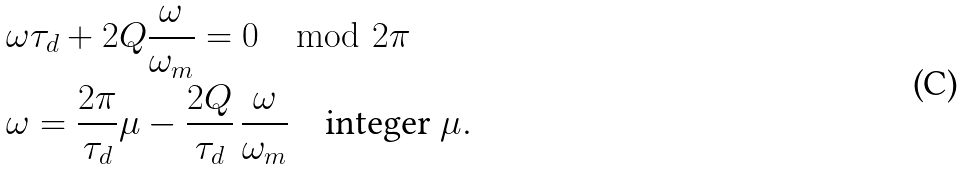<formula> <loc_0><loc_0><loc_500><loc_500>& \omega \tau _ { d } + 2 Q \frac { \omega } { \omega _ { m } } = 0 \mod 2 \pi \\ & \omega = \frac { 2 \pi } { \tau _ { d } } \mu - \frac { 2 Q } { \tau _ { d } } \, \frac { \omega } { \omega _ { m } } \quad \text {integer $\mu$} .</formula> 